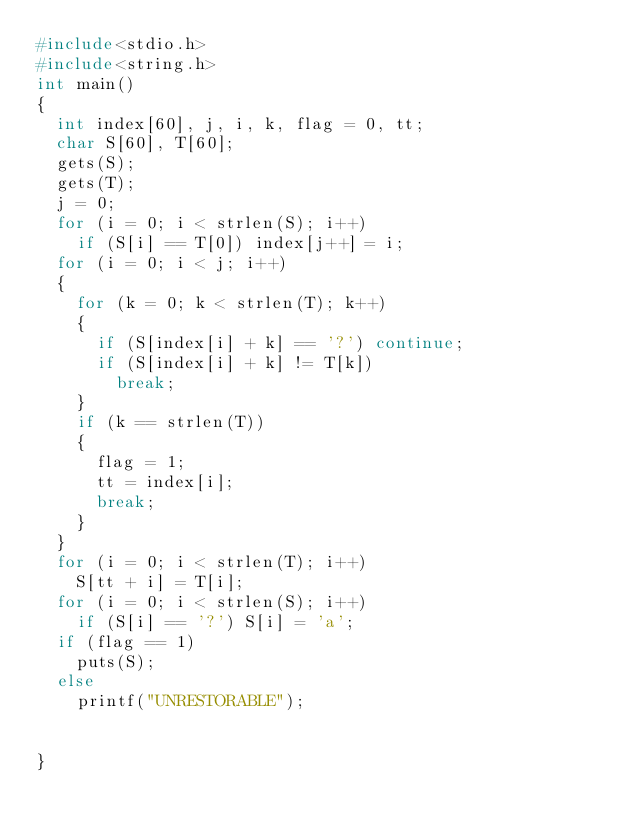<code> <loc_0><loc_0><loc_500><loc_500><_C_>#include<stdio.h>
#include<string.h>
int main()
{
	int index[60], j, i, k, flag = 0, tt;
	char S[60], T[60];
	gets(S);
	gets(T);
	j = 0;
	for (i = 0; i < strlen(S); i++)
		if (S[i] == T[0]) index[j++] = i;
	for (i = 0; i < j; i++)
	{
		for (k = 0; k < strlen(T); k++)
		{
			if (S[index[i] + k] == '?') continue;
			if (S[index[i] + k] != T[k])
				break;
		}
		if (k == strlen(T))
		{
			flag = 1;
			tt = index[i];
			break;
		}
	}
	for (i = 0; i < strlen(T); i++)
		S[tt + i] = T[i];
	for (i = 0; i < strlen(S); i++)
		if (S[i] == '?') S[i] = 'a';
	if (flag == 1)
		puts(S);
	else
		printf("UNRESTORABLE");


}</code> 